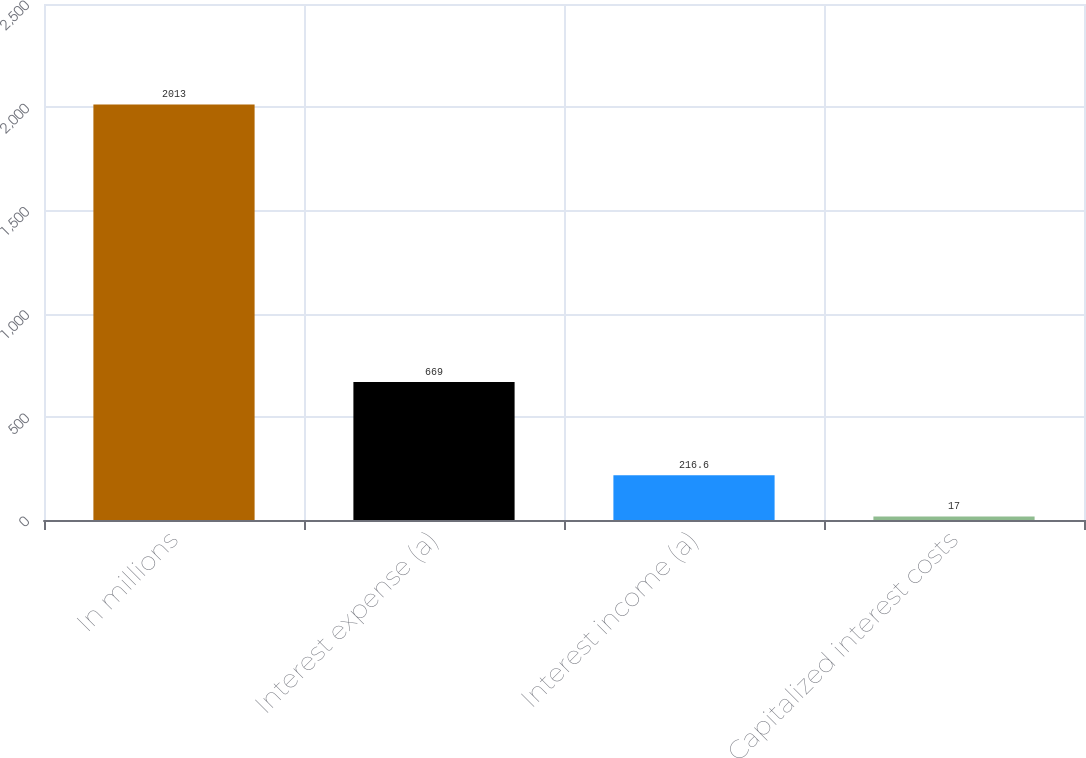Convert chart. <chart><loc_0><loc_0><loc_500><loc_500><bar_chart><fcel>In millions<fcel>Interest expense (a)<fcel>Interest income (a)<fcel>Capitalized interest costs<nl><fcel>2013<fcel>669<fcel>216.6<fcel>17<nl></chart> 